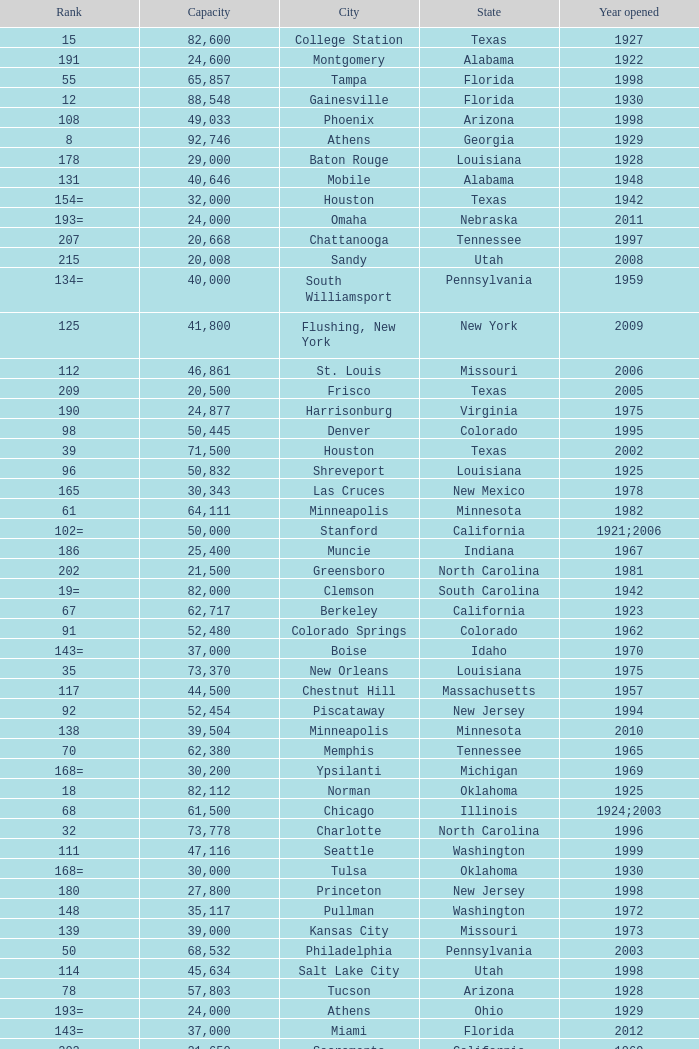What is the city in Alabama that opened in 1996? Huntsville. 